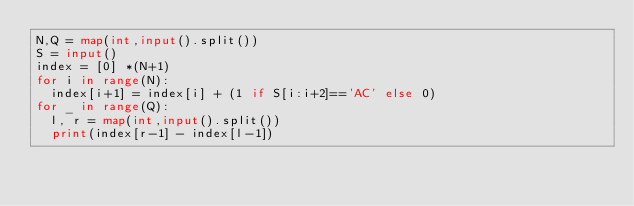<code> <loc_0><loc_0><loc_500><loc_500><_Python_>N,Q = map(int,input().split())
S = input()
index = [0] *(N+1)
for i in range(N):
  index[i+1] = index[i] + (1 if S[i:i+2]=='AC' else 0)
for _ in range(Q):
  l, r = map(int,input().split())
  print(index[r-1] - index[l-1])</code> 